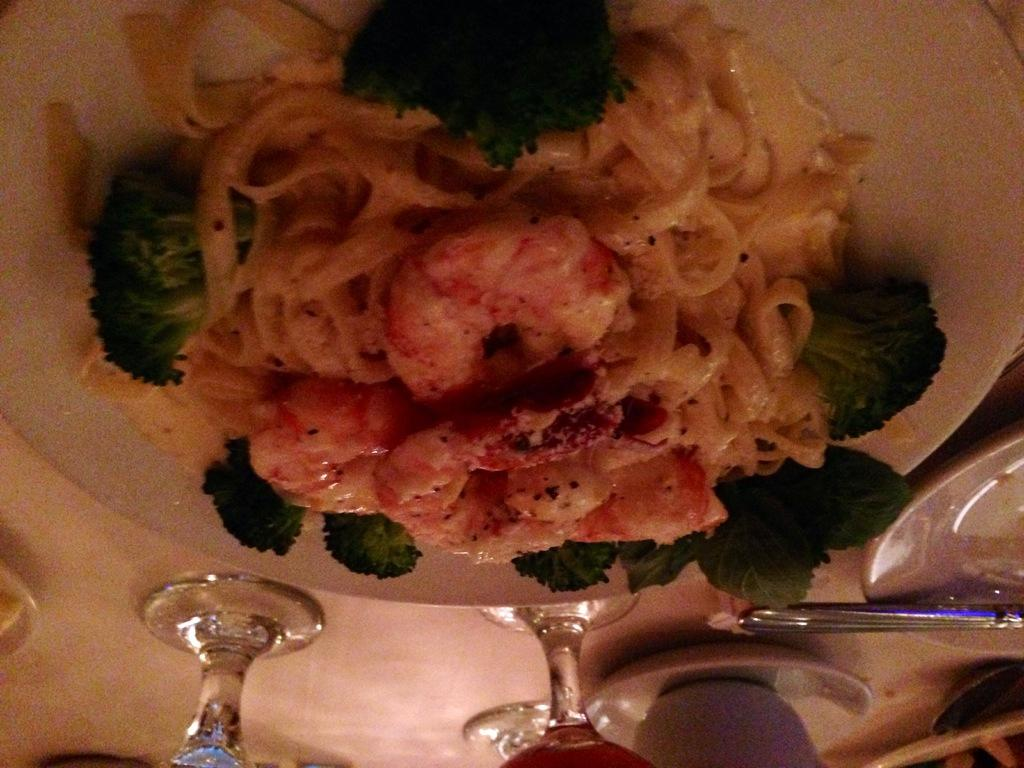What is on the plate that is visible in the image? The plate contains food items. What other items can be seen at the bottom of the image? There are glass and cups at the bottom of the image, along with a few other objects. How many quarters are visible on the plate in the image? There are no quarters present on the plate or in the image. Is there any dirt visible on the plate or the other objects in the image? There is no dirt visible on the plate or the other objects in the image. 